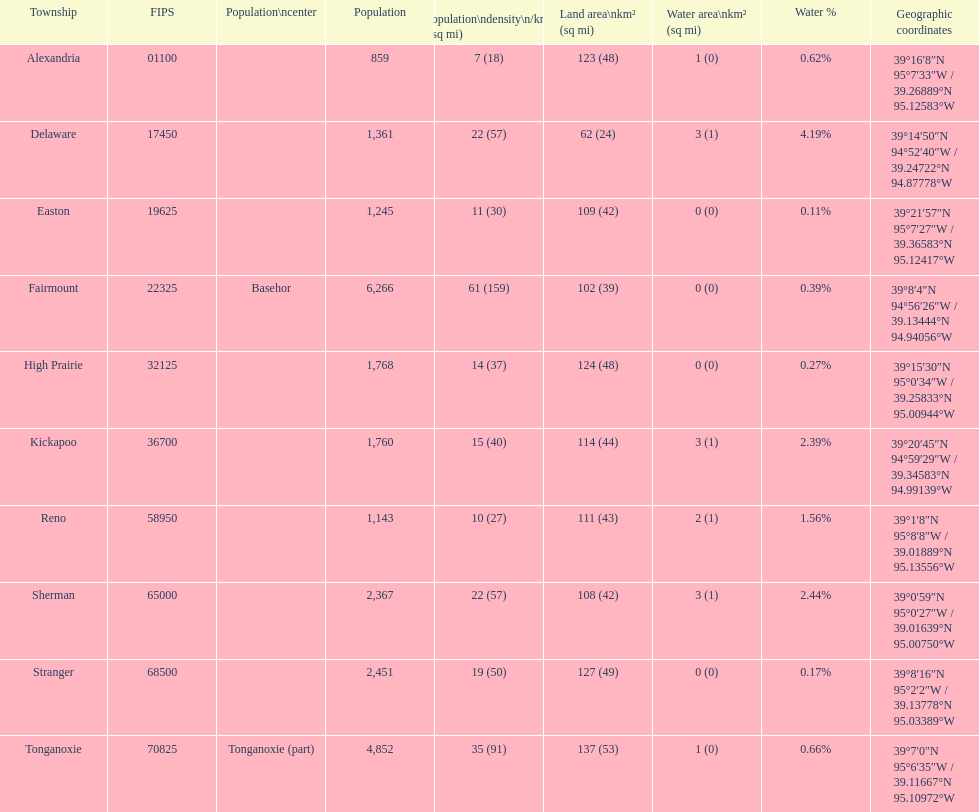Which township has the least land area? Delaware. 